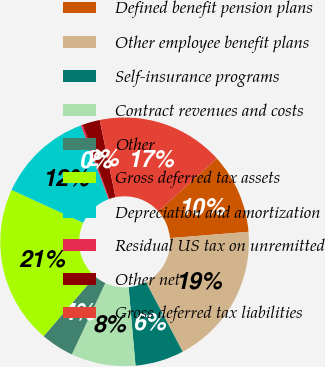Convert chart. <chart><loc_0><loc_0><loc_500><loc_500><pie_chart><fcel>Defined benefit pension plans<fcel>Other employee benefit plans<fcel>Self-insurance programs<fcel>Contract revenues and costs<fcel>Other<fcel>Gross deferred tax assets<fcel>Depreciation and amortization<fcel>Residual US tax on unremitted<fcel>Other net<fcel>Gross deferred tax liabilities<nl><fcel>10.41%<fcel>18.54%<fcel>6.34%<fcel>8.37%<fcel>4.31%<fcel>20.57%<fcel>12.44%<fcel>0.24%<fcel>2.27%<fcel>16.51%<nl></chart> 